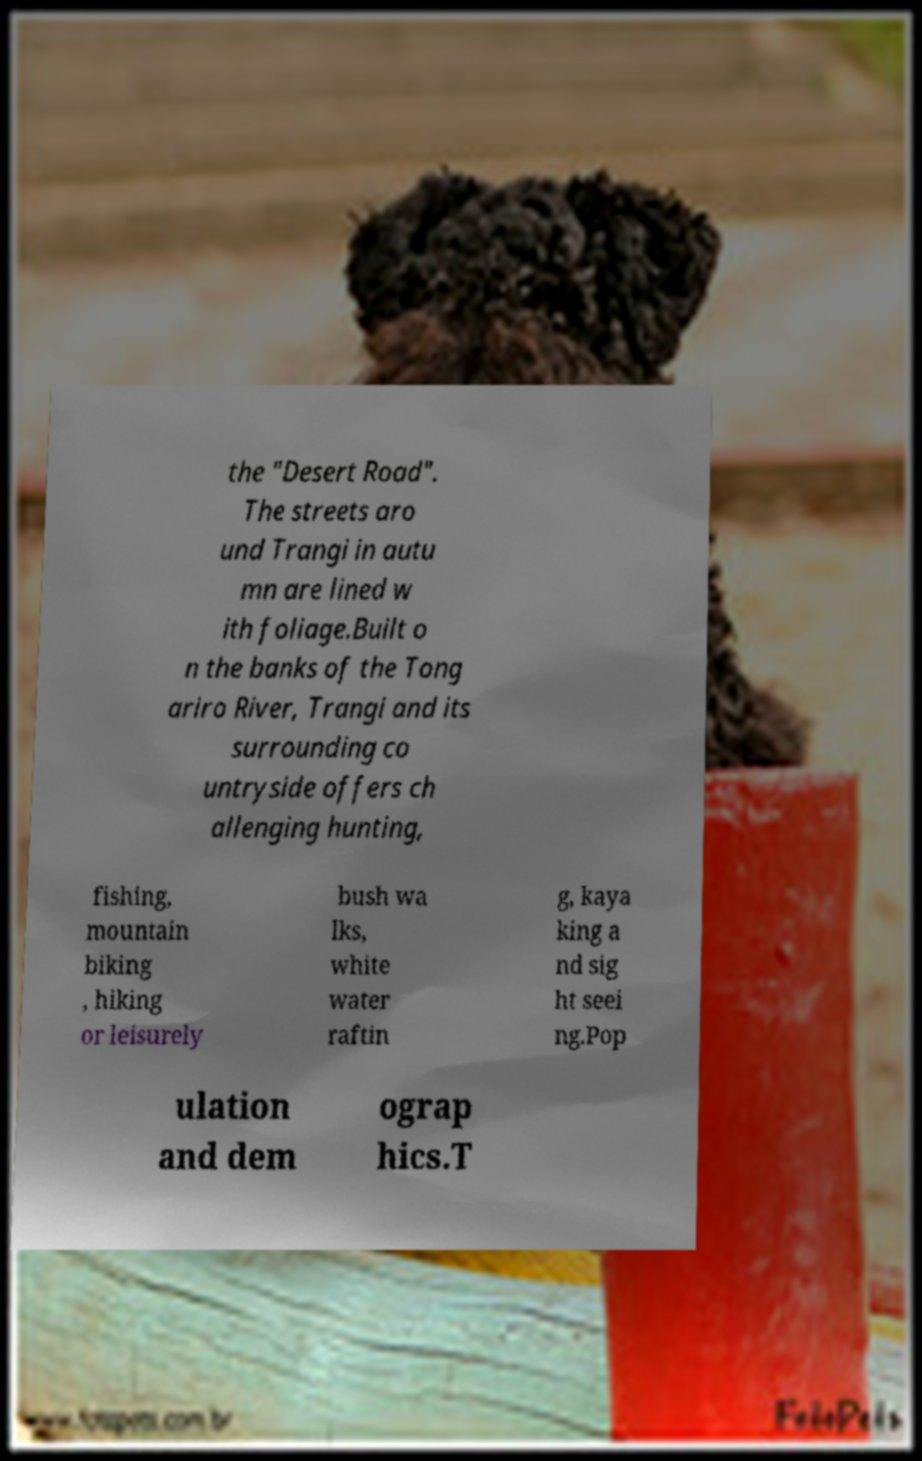Please read and relay the text visible in this image. What does it say? the "Desert Road". The streets aro und Trangi in autu mn are lined w ith foliage.Built o n the banks of the Tong ariro River, Trangi and its surrounding co untryside offers ch allenging hunting, fishing, mountain biking , hiking or leisurely bush wa lks, white water raftin g, kaya king a nd sig ht seei ng.Pop ulation and dem ograp hics.T 